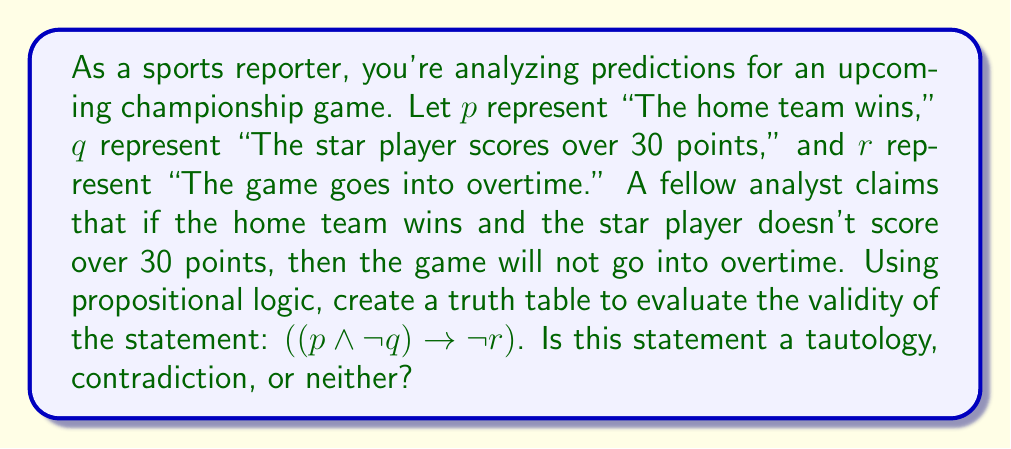What is the answer to this math problem? To evaluate the validity of the given statement, we need to construct a truth table and examine all possible outcomes. Let's break this down step-by-step:

1) First, we identify the atomic propositions: $p$, $q$, and $r$.

2) We then construct a truth table with all possible combinations of truth values for these propositions:

   $$
   \begin{array}{|c|c|c|c|c|c|c|}
   \hline
   p & q & r & \neg q & p \wedge \neg q & \neg r & ((p \wedge \neg q) \rightarrow \neg r) \\
   \hline
   T & T & T & F & F & F & T \\
   T & T & F & F & F & T & T \\
   T & F & T & T & T & F & F \\
   T & F & F & T & T & T & T \\
   F & T & T & F & F & F & T \\
   F & T & F & F & F & T & T \\
   F & F & T & T & F & F & T \\
   F & F & F & T & F & T & T \\
   \hline
   \end{array}
   $$

3) We evaluate each column:
   - $\neg q$ is true when $q$ is false
   - $p \wedge \neg q$ is true only when both $p$ is true and $q$ is false
   - $\neg r$ is true when $r$ is false
   - The implication $(p \wedge \neg q) \rightarrow \neg r$ is false only when $(p \wedge \neg q)$ is true and $\neg r$ is false

4) Looking at the final column, we see that the statement is true in all cases except one (when $p$ is true, $q$ is false, and $r$ is true).

5) For a statement to be a tautology, it must be true in all possible cases. For it to be a contradiction, it must be false in all possible cases. Since this statement is true in all but one case, it is neither a tautology nor a contradiction.
Answer: The statement $((p \wedge \neg q) \rightarrow \neg r)$ is neither a tautology nor a contradiction. It is a contingency, as its truth value depends on the truth values of its component propositions. 